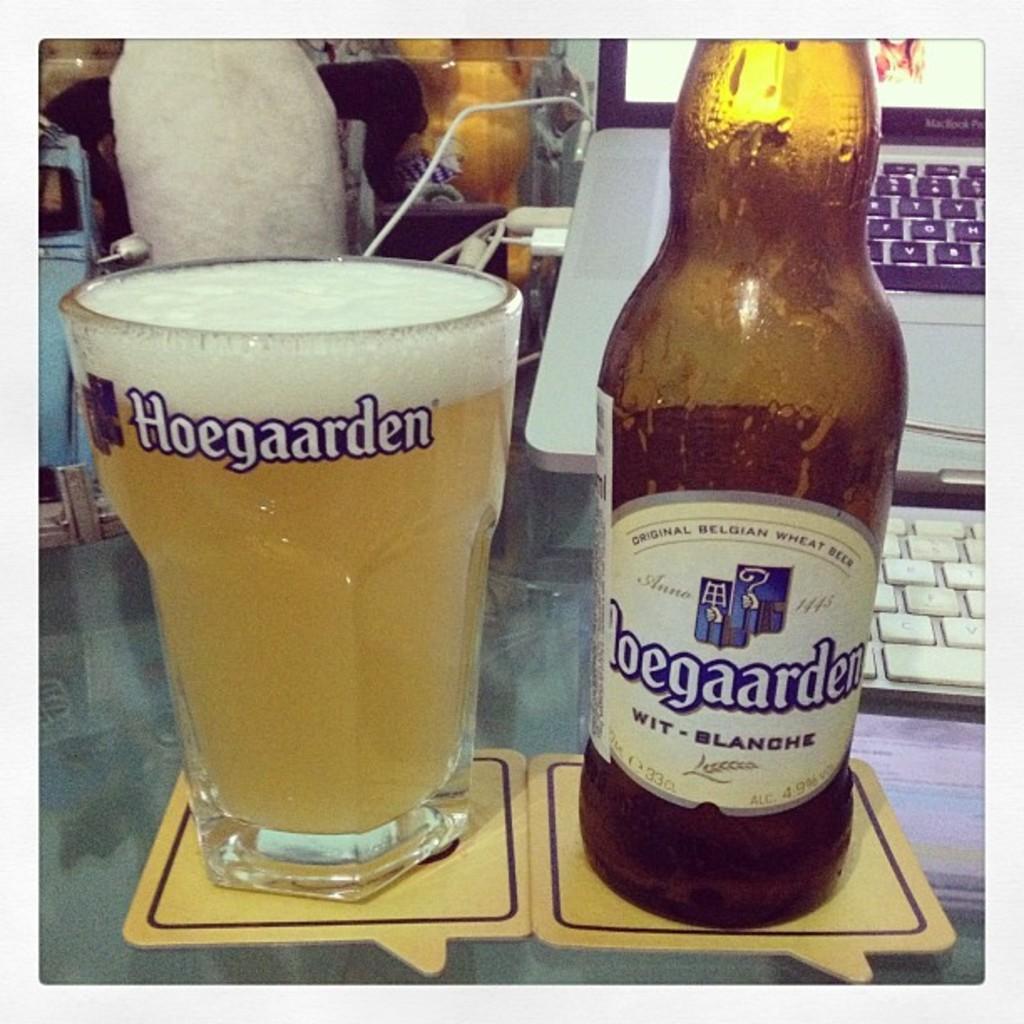Please provide a concise description of this image. In this image I can see a glass of wine and a bottle is on the table. The brand name is "Hoegaarden" is written on the bottle and glass. On the table there is a laptop. 